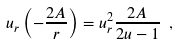<formula> <loc_0><loc_0><loc_500><loc_500>u _ { r } \left ( - \frac { 2 A } { r } \right ) = u _ { r } ^ { 2 } \frac { 2 A } { 2 u - 1 } \ ,</formula> 